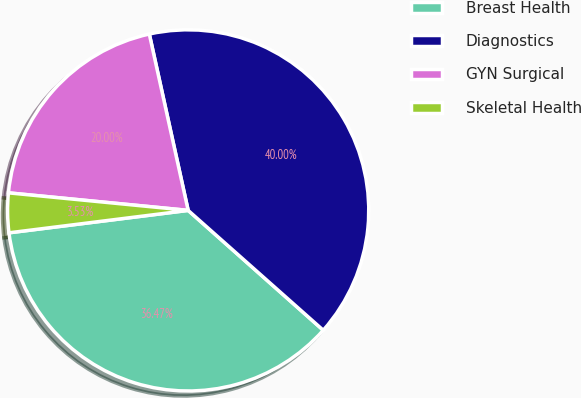Convert chart to OTSL. <chart><loc_0><loc_0><loc_500><loc_500><pie_chart><fcel>Breast Health<fcel>Diagnostics<fcel>GYN Surgical<fcel>Skeletal Health<nl><fcel>36.47%<fcel>40.0%<fcel>20.0%<fcel>3.53%<nl></chart> 